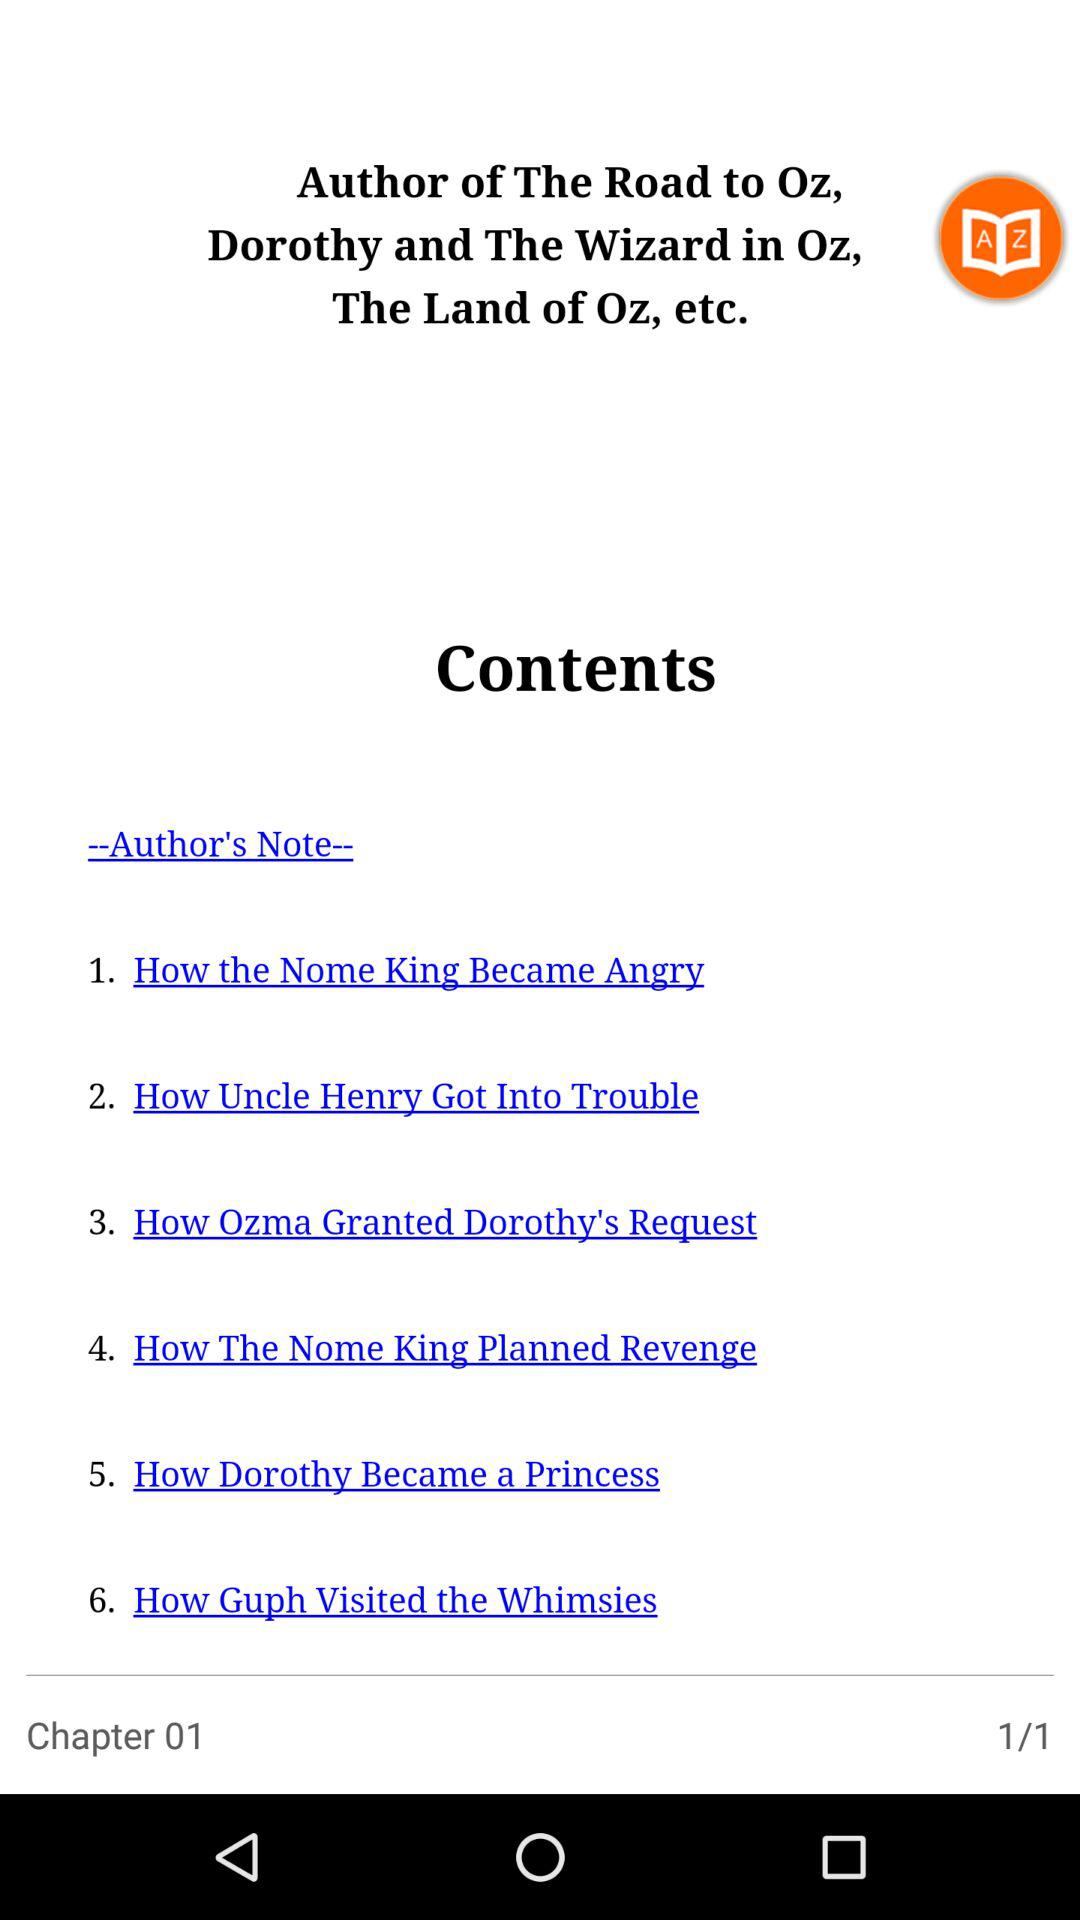How many chapters are there in the book?
Answer the question using a single word or phrase. 6 